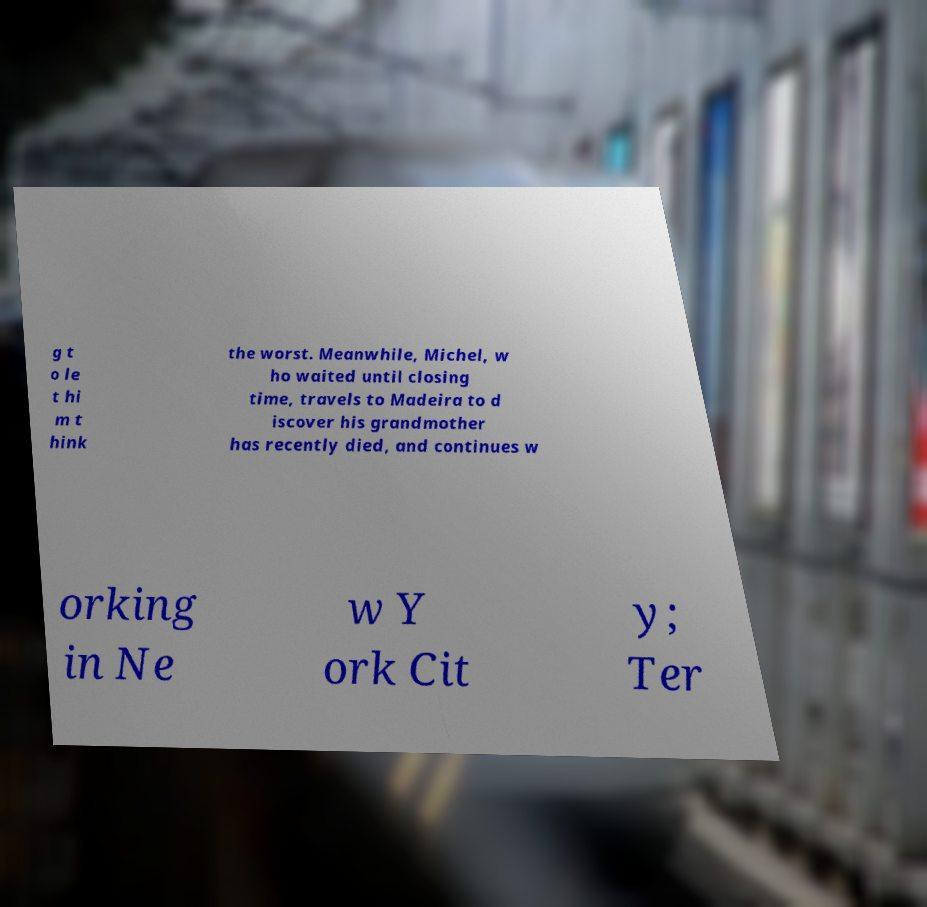For documentation purposes, I need the text within this image transcribed. Could you provide that? g t o le t hi m t hink the worst. Meanwhile, Michel, w ho waited until closing time, travels to Madeira to d iscover his grandmother has recently died, and continues w orking in Ne w Y ork Cit y; Ter 